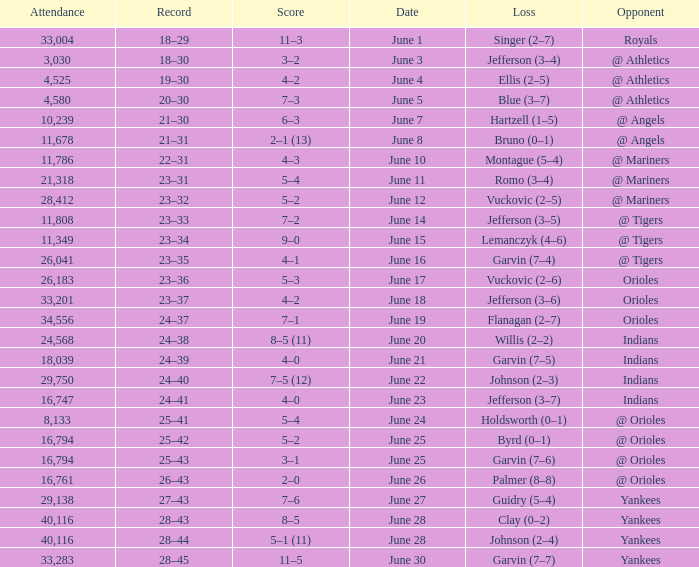Who was the opponent at the game when the record was 28–45? Yankees. 